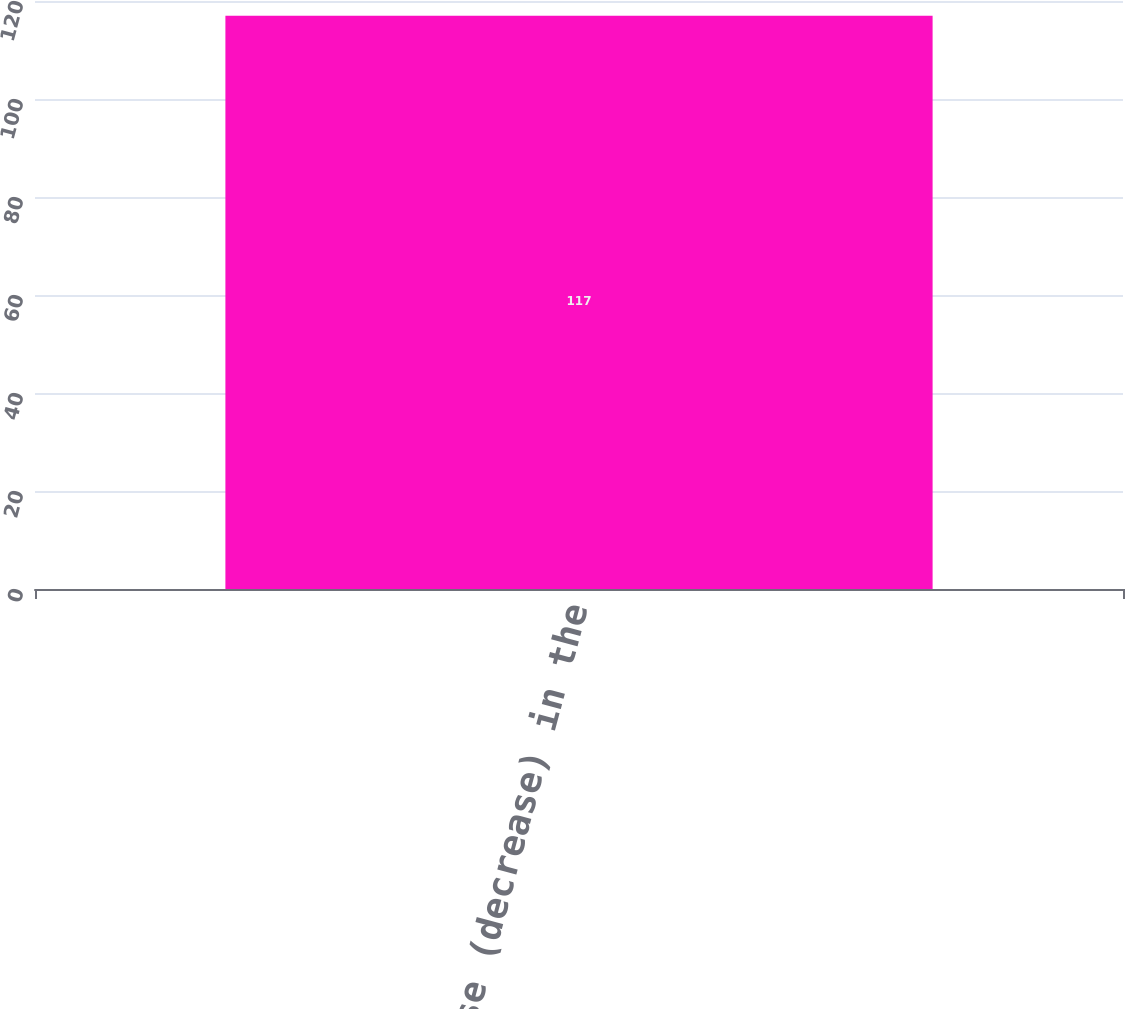<chart> <loc_0><loc_0><loc_500><loc_500><bar_chart><fcel>Increase (decrease) in the<nl><fcel>117<nl></chart> 